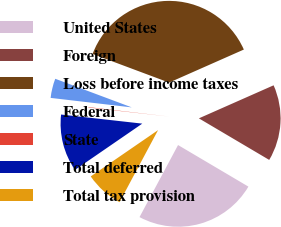Convert chart to OTSL. <chart><loc_0><loc_0><loc_500><loc_500><pie_chart><fcel>United States<fcel>Foreign<fcel>Loss before income taxes<fcel>Federal<fcel>State<fcel>Total deferred<fcel>Total tax provision<nl><fcel>24.32%<fcel>15.12%<fcel>37.68%<fcel>3.84%<fcel>0.08%<fcel>11.36%<fcel>7.6%<nl></chart> 